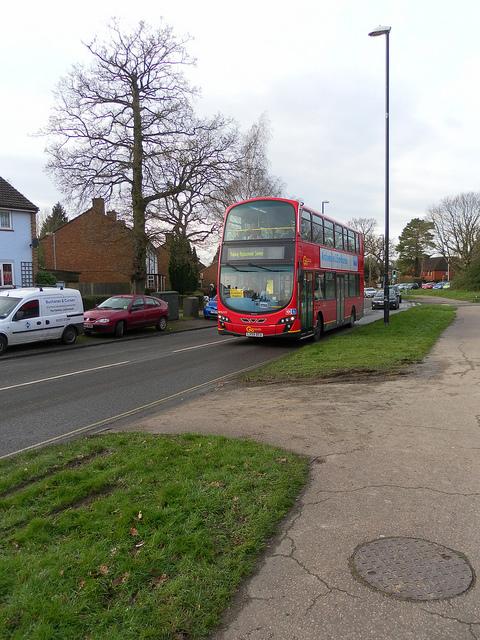How many levels to the bus?
Answer briefly. 2. What is the grass for?
Short answer required. Decoration. Is the grass green?
Answer briefly. Yes. 